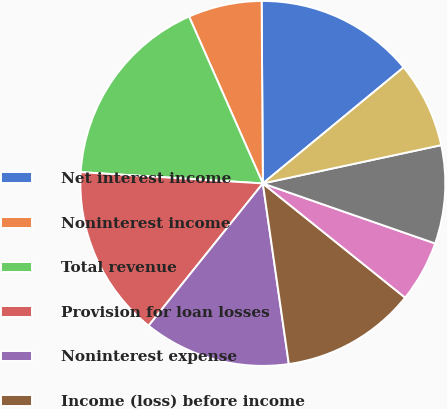Convert chart. <chart><loc_0><loc_0><loc_500><loc_500><pie_chart><fcel>Net interest income<fcel>Noninterest income<fcel>Total revenue<fcel>Provision for loan losses<fcel>Noninterest expense<fcel>Income (loss) before income<fcel>Income taxes (benefit)<fcel>Net income (loss)<fcel>Net income (loss) applicable<nl><fcel>14.13%<fcel>6.52%<fcel>17.39%<fcel>15.22%<fcel>13.04%<fcel>11.96%<fcel>5.43%<fcel>8.7%<fcel>7.61%<nl></chart> 